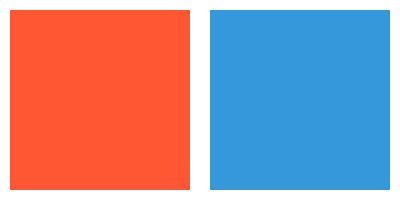Compare the emotional impact of the two color palettes shown above in the context of abstract expressionist art. Which palette would likely evoke a more intense, passionate response from viewers, and why? To analyze the emotional impact of these color palettes in abstract expressionist art, we need to consider the following steps:

1. Identify the colors:
   Left palette: Warm orange-red (#FF5733)
   Right palette: Cool blue (#3498DB)

2. Understand color psychology:
   - Warm colors (like orange-red) are associated with energy, passion, and intensity.
   - Cool colors (like blue) are associated with calmness, serenity, and tranquility.

3. Consider the context of abstract expressionism:
   - Abstract expressionism often aims to evoke strong emotional responses.
   - The movement emphasizes spontaneous, intuitive creation and the expression of the artist's inner world.

4. Analyze the impact of each palette:
   - The warm orange-red palette:
     * Evokes feelings of excitement, urgency, and emotional intensity.
     * Aligns with the passionate, expressive nature of abstract expressionism.
     * Can create a sense of movement and energy in the artwork.

   - The cool blue palette:
     * Evokes feelings of calmness, introspection, and emotional distance.
     * Can create a sense of depth and space in the artwork.
     * May be less immediately impactful in terms of raw emotion.

5. Consider the viewer's response:
   - The warm palette is likely to elicit a more immediate, visceral reaction.
   - The cool palette may encourage longer contemplation but with less emotional intensity.

Given the emphasis on emotional expression in abstract expressionism, the warm orange-red palette would likely evoke a more intense, passionate response from viewers. Its association with energy and intensity aligns more closely with the movement's goals of conveying raw emotion and inner turmoil.
Answer: The warm orange-red palette, evoking intensity and passion. 